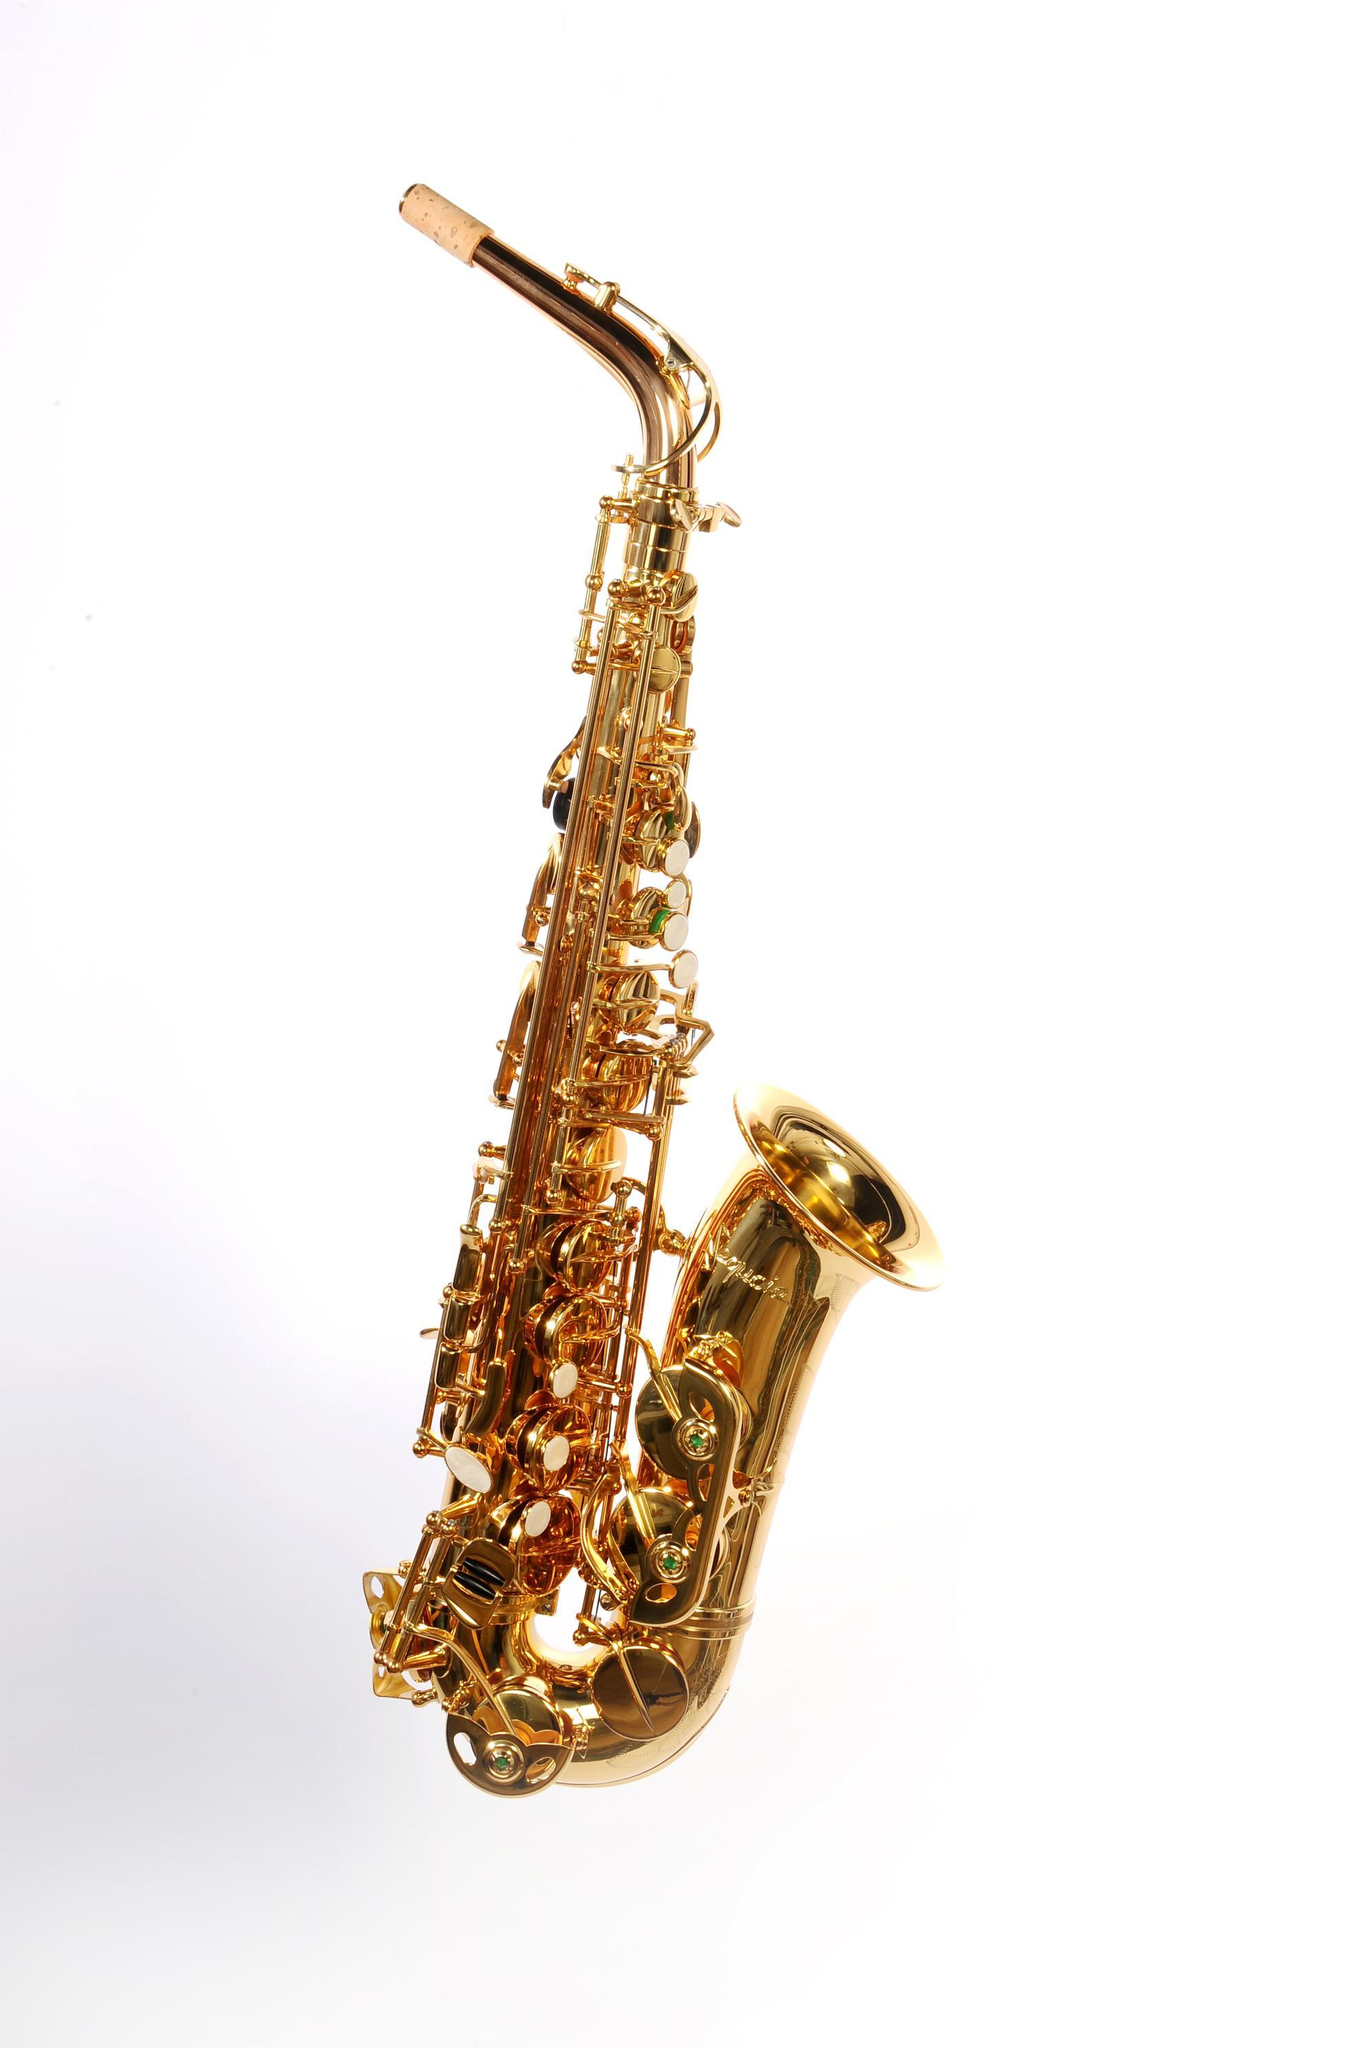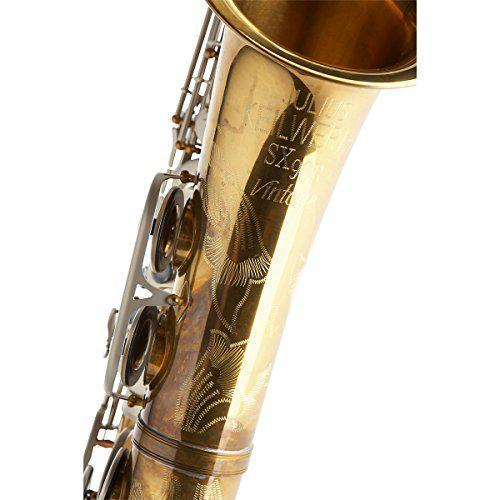The first image is the image on the left, the second image is the image on the right. For the images displayed, is the sentence "The mouthpiece is visible in both images." factually correct? Answer yes or no. No. The first image is the image on the left, the second image is the image on the right. Evaluate the accuracy of this statement regarding the images: "The left image shows one saxophone displayed upright with its bell facing right, and the right image shows decorative etching embellishing the bell-end of a saxophone.". Is it true? Answer yes or no. Yes. 